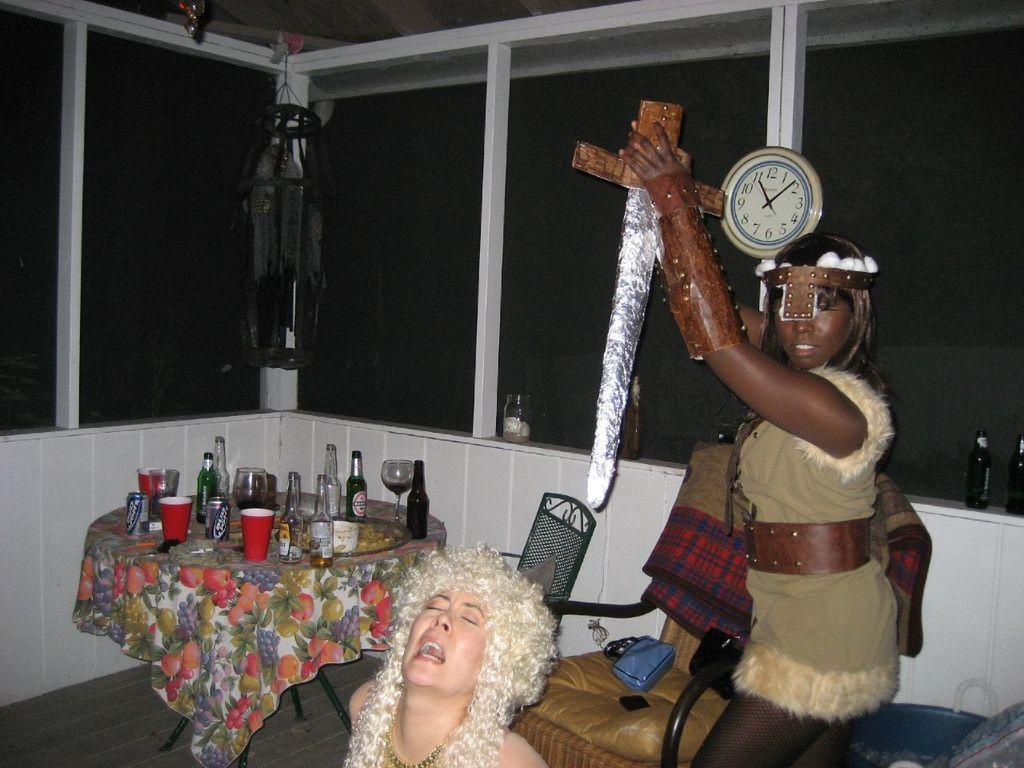<image>
Provide a brief description of the given image. 2 women are posing near a table with empty bottles of Corona on it. 